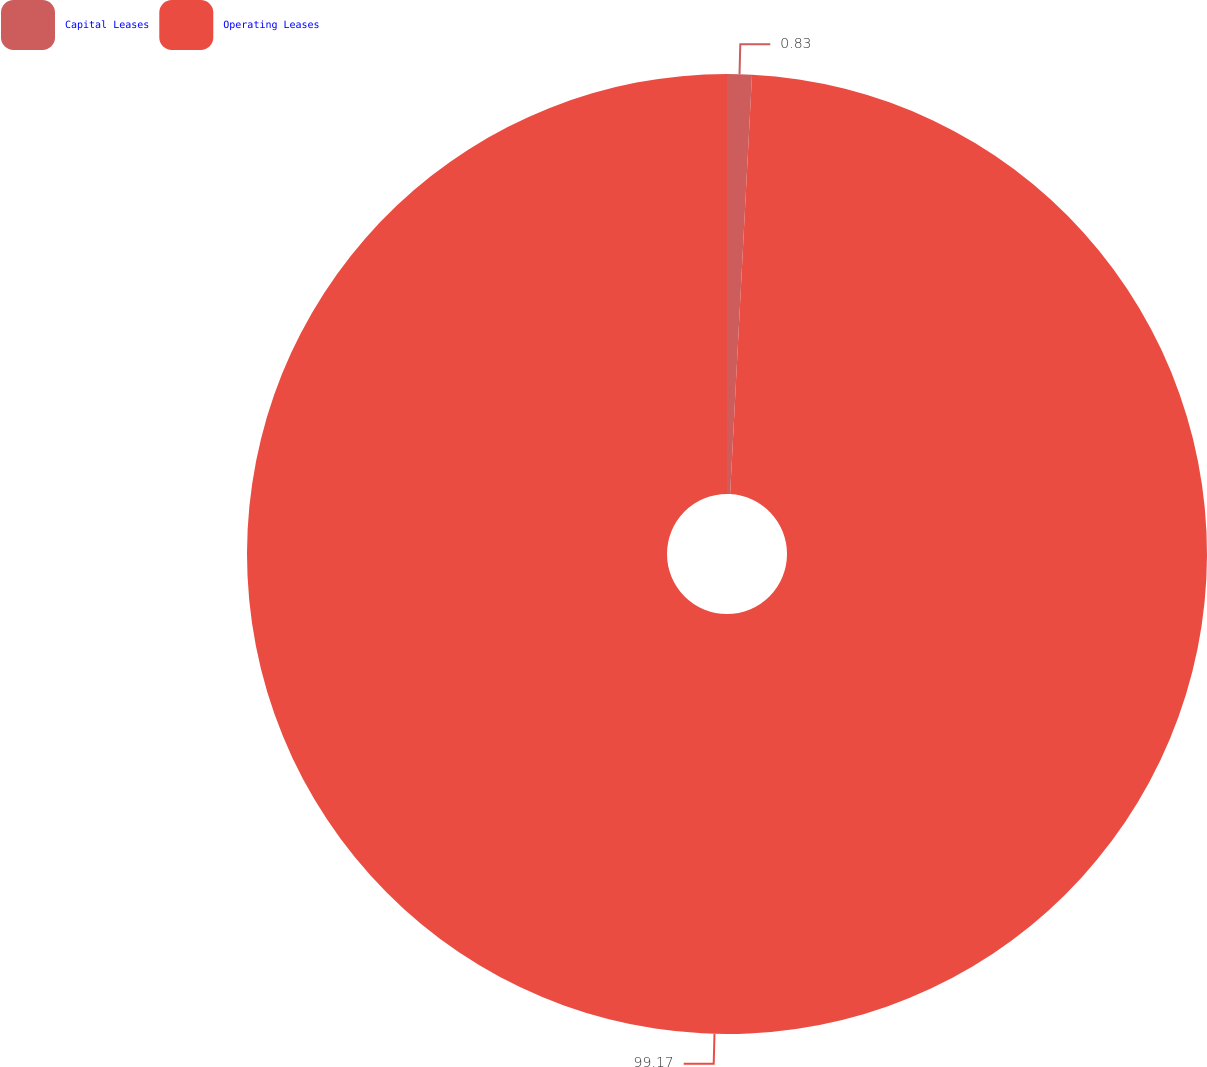Convert chart. <chart><loc_0><loc_0><loc_500><loc_500><pie_chart><fcel>Capital Leases<fcel>Operating Leases<nl><fcel>0.83%<fcel>99.17%<nl></chart> 